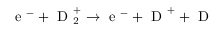<formula> <loc_0><loc_0><loc_500><loc_500>e ^ { - } + D _ { 2 } ^ { + } \rightarrow e ^ { - } + D ^ { + } + D</formula> 